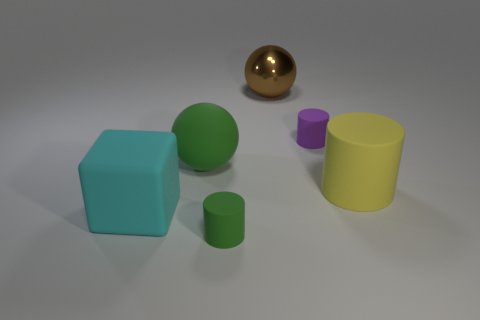There is a block that is the same material as the large yellow object; what color is it? The block that shares the same material as the large yellow object is cyan in color, exhibiting a pleasant pastel shade that harmonizes with the scene's soft lighting and muted palette. 